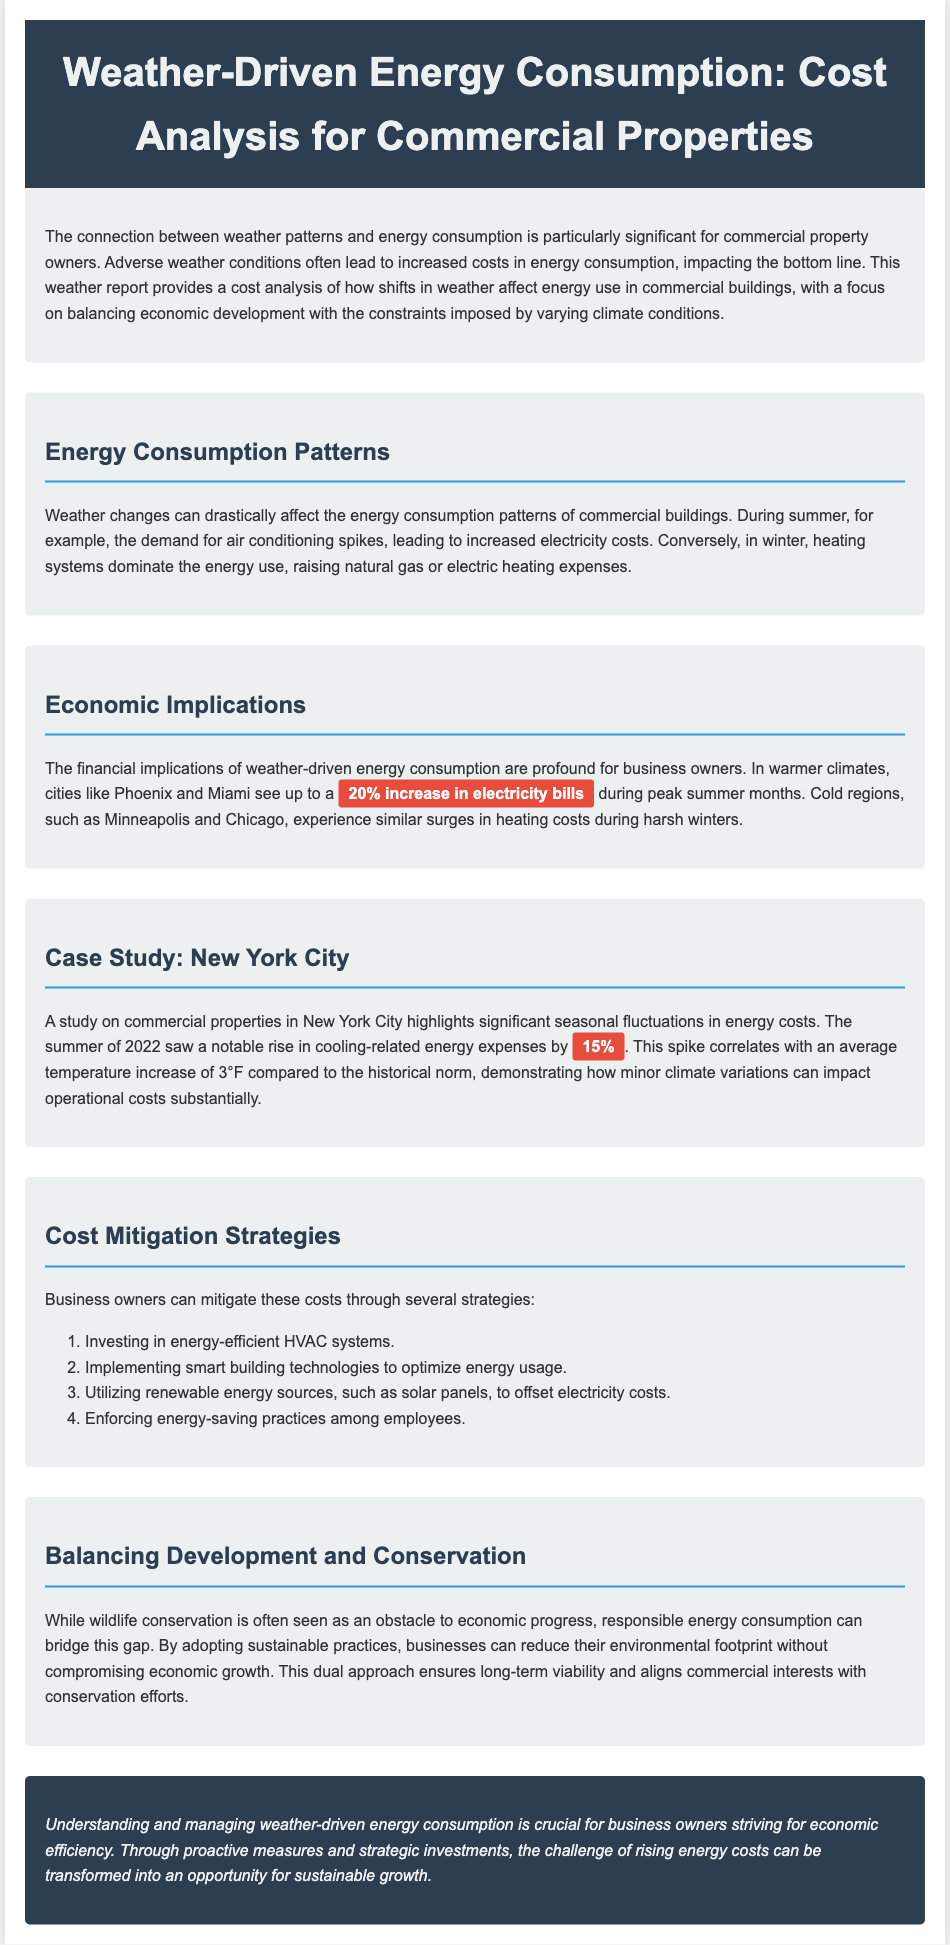What is the title of the report? The title of the report is stated in the header of the document.
Answer: Weather-Driven Energy Consumption: Cost Analysis for Commercial Properties What seasonal fluctuation was highlighted for New York City? The document mentions a specific seasonal fluctuation related to energy costs for New York City.
Answer: 15% increase What percentage increase in electricity bills is reported for warmer climates? The document provides a percentage regarding electricity bills in warmer climates during peak summer months.
Answer: 20% increase What is one cost mitigation strategy suggested for business owners? The document lists various strategies business owners can use to reduce energy costs.
Answer: Investing in energy-efficient HVAC systems Which cities see a significant rise in electricity costs during the summer? The document mentions specific cities that experience increased electricity bills during summer months.
Answer: Phoenix and Miami How much did the average temperature increase in New York City in 2022? The report provides a specific temperature change that corresponds with energy cost increases.
Answer: 3°F What approach does the document suggest for balancing development and conservation? The document discusses a method for aligning economic and environmental interests.
Answer: Sustainable practices What does the conclusion emphasize for business owners? The conclusion provides a key takeaway regarding managing energy consumption.
Answer: Economic efficiency What weather condition primarily affects heating system costs in winter? The report explains the impact of a specific weather condition on energy costs during winter.
Answer: Cold weather 